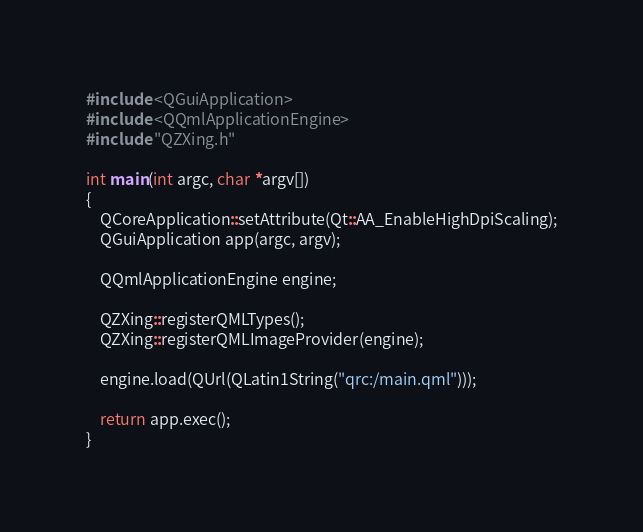<code> <loc_0><loc_0><loc_500><loc_500><_C++_>#include <QGuiApplication>
#include <QQmlApplicationEngine>
#include "QZXing.h"

int main(int argc, char *argv[])
{
    QCoreApplication::setAttribute(Qt::AA_EnableHighDpiScaling);
    QGuiApplication app(argc, argv);

    QQmlApplicationEngine engine;

    QZXing::registerQMLTypes();
    QZXing::registerQMLImageProvider(engine);

    engine.load(QUrl(QLatin1String("qrc:/main.qml")));

    return app.exec();
}

</code> 